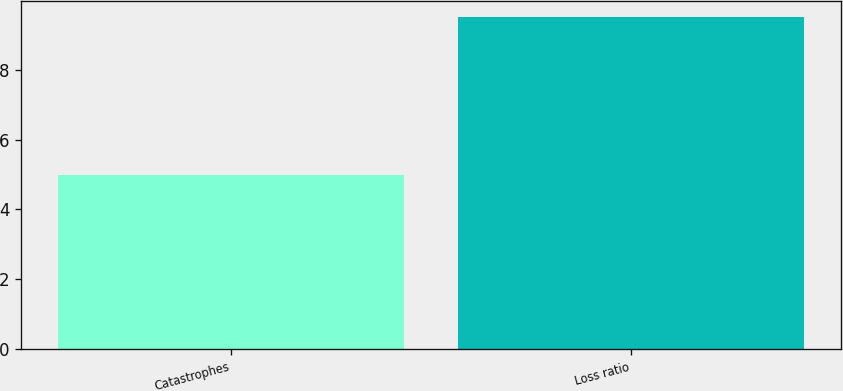<chart> <loc_0><loc_0><loc_500><loc_500><bar_chart><fcel>Catastrophes<fcel>Loss ratio<nl><fcel>5<fcel>9.5<nl></chart> 